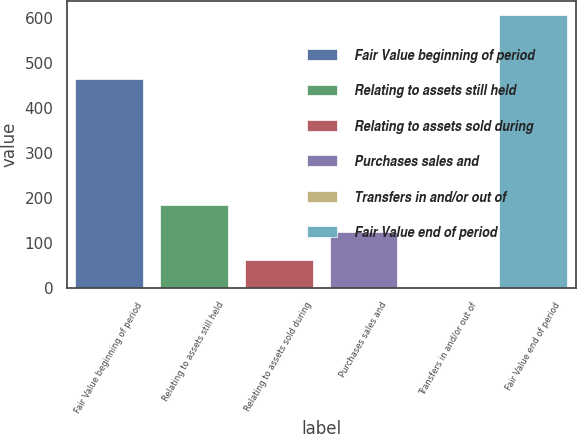Convert chart. <chart><loc_0><loc_0><loc_500><loc_500><bar_chart><fcel>Fair Value beginning of period<fcel>Relating to assets still held<fcel>Relating to assets sold during<fcel>Purchases sales and<fcel>Transfers in and/or out of<fcel>Fair Value end of period<nl><fcel>465<fcel>183.45<fcel>62.43<fcel>122.94<fcel>1.92<fcel>607<nl></chart> 